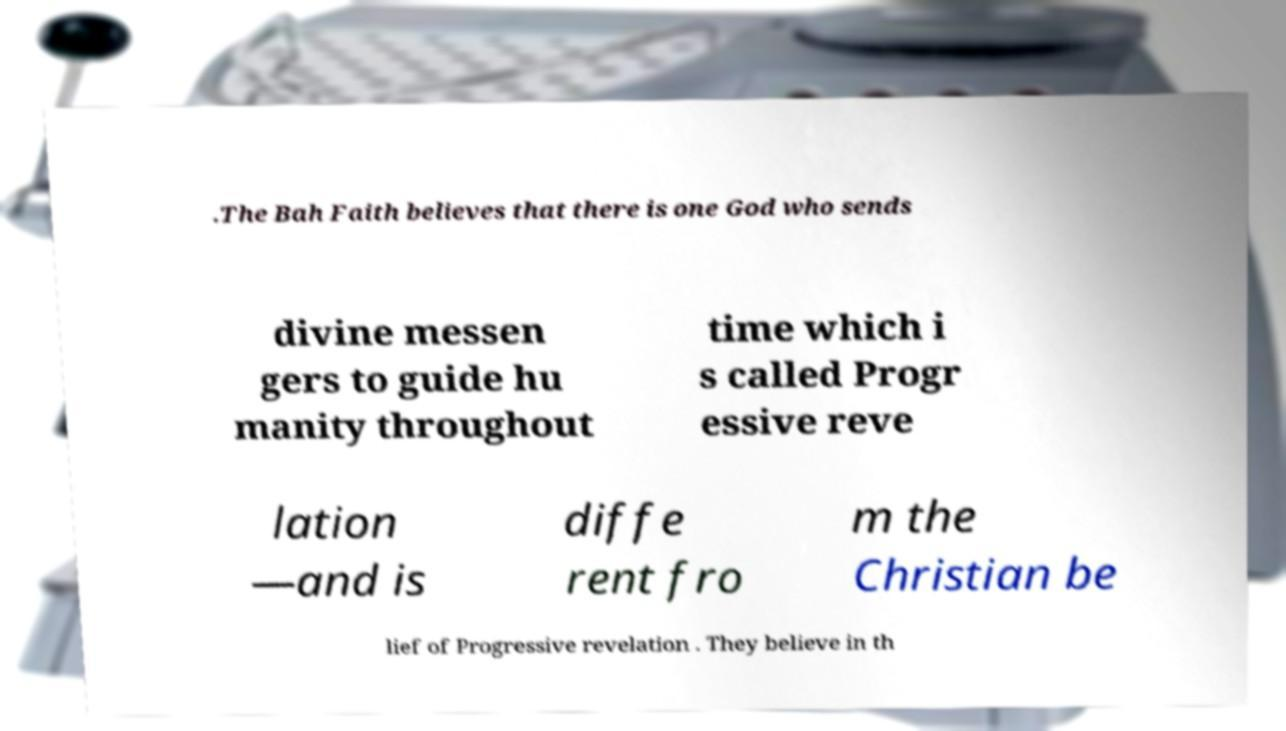Can you accurately transcribe the text from the provided image for me? .The Bah Faith believes that there is one God who sends divine messen gers to guide hu manity throughout time which i s called Progr essive reve lation —and is diffe rent fro m the Christian be lief of Progressive revelation . They believe in th 